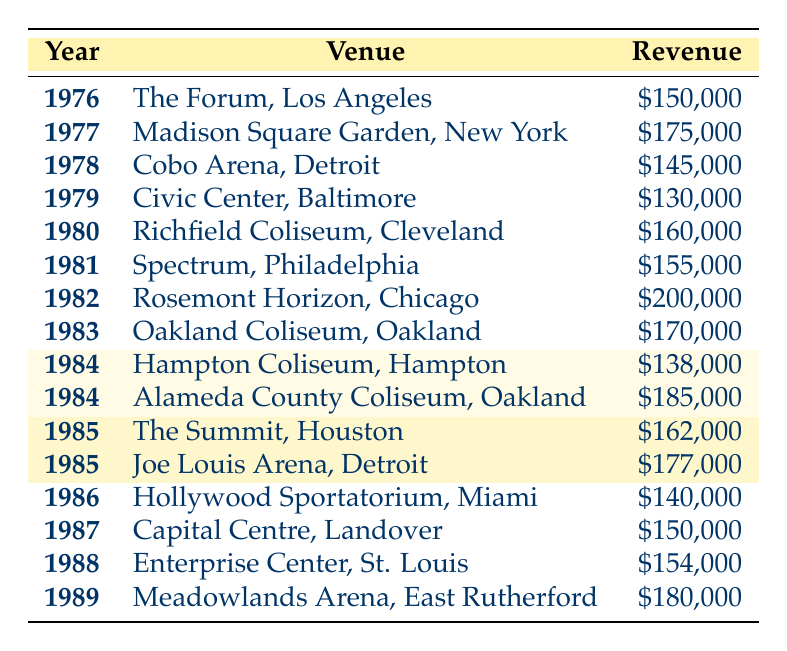What was the highest concert revenue achieved by Styx in the 70s and 80s? By reviewing the concert revenue figures in the table, I find that the highest revenue recorded is 200,000 at the Rosemont Horizon in Chicago in 1982.
Answer: 200,000 Which venue generated the most revenue for Styx in 1985? There are two entries for 1985: The Summit in Houston with a revenue of 162,000 and Joe Louis Arena in Detroit with a revenue of 177,000. The one with the higher revenue is Joe Louis Arena.
Answer: Joe Louis Arena, 177,000 What was the total concert revenue from venues in Oakland? There are two revenues listed for Oakland: 170,000 from the Oakland Coliseum in 1983 and 185,000 from the Alameda County Coliseum in 1984. Adding these gives (170,000 + 185,000 = 355,000).
Answer: 355,000 Did Styx perform at Madison Square Garden in any year? The table indicates that Styx performed at Madison Square Garden in New York in 1977, which confirms that they did perform there.
Answer: Yes What was the revenue difference between concerts at the Civic Center in Baltimore and the Richfield Coliseum in Cleveland? The Civic Center in Baltimore in 1979 had a revenue of 130,000, while the Richfield Coliseum in Cleveland in 1980 had a revenue of 160,000. The difference is calculated by subtracting 130,000 from 160,000, resulting in 30,000.
Answer: 30,000 What was the average revenue for Styx's concerts in 1984? Two venues are listed for 1984: Hampton Coliseum with 138,000 and Alameda County Coliseum with 185,000. The average revenue is calculated by summing these values (138,000 + 185,000 = 323,000) and dividing by the number of venues (323,000 / 2 = 161,500).
Answer: 161,500 Did all concert revenues in 1986 exceed 140,000? The only concert revenue recorded for 1986 is 140,000 from the Hollywood Sportatorium in Miami, thus it does not exceed 140,000.
Answer: No Which year had the lowest concert revenue, and how much was it? Looking at all the years, the lowest revenue is 130,000 from the Civic Center in Baltimore in 1979.
Answer: 1979, 130,000 